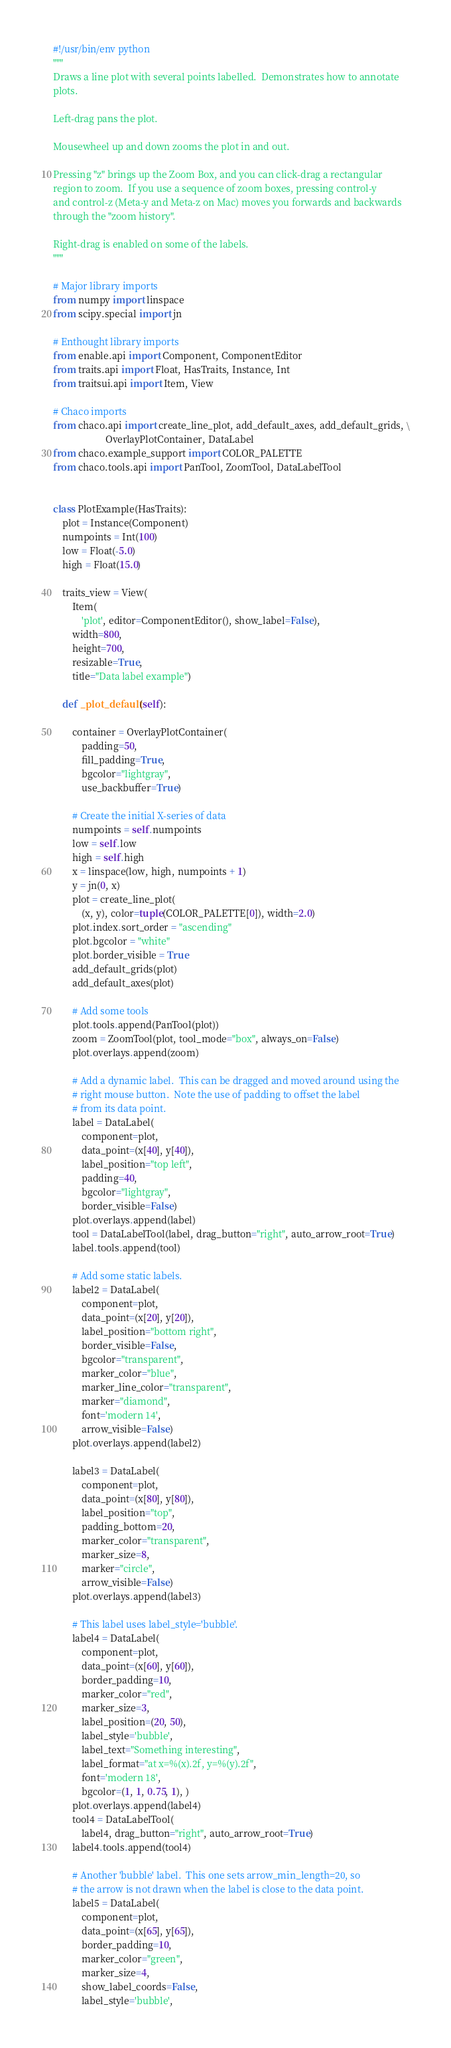<code> <loc_0><loc_0><loc_500><loc_500><_Python_>#!/usr/bin/env python
"""
Draws a line plot with several points labelled.  Demonstrates how to annotate
plots.

Left-drag pans the plot.

Mousewheel up and down zooms the plot in and out.

Pressing "z" brings up the Zoom Box, and you can click-drag a rectangular
region to zoom.  If you use a sequence of zoom boxes, pressing control-y
and control-z (Meta-y and Meta-z on Mac) moves you forwards and backwards
through the "zoom history".

Right-drag is enabled on some of the labels.
"""

# Major library imports
from numpy import linspace
from scipy.special import jn

# Enthought library imports
from enable.api import Component, ComponentEditor
from traits.api import Float, HasTraits, Instance, Int
from traitsui.api import Item, View

# Chaco imports
from chaco.api import create_line_plot, add_default_axes, add_default_grids, \
                      OverlayPlotContainer, DataLabel
from chaco.example_support import COLOR_PALETTE
from chaco.tools.api import PanTool, ZoomTool, DataLabelTool


class PlotExample(HasTraits):
    plot = Instance(Component)
    numpoints = Int(100)
    low = Float(-5.0)
    high = Float(15.0)

    traits_view = View(
        Item(
            'plot', editor=ComponentEditor(), show_label=False),
        width=800,
        height=700,
        resizable=True,
        title="Data label example")

    def _plot_default(self):

        container = OverlayPlotContainer(
            padding=50,
            fill_padding=True,
            bgcolor="lightgray",
            use_backbuffer=True)

        # Create the initial X-series of data
        numpoints = self.numpoints
        low = self.low
        high = self.high
        x = linspace(low, high, numpoints + 1)
        y = jn(0, x)
        plot = create_line_plot(
            (x, y), color=tuple(COLOR_PALETTE[0]), width=2.0)
        plot.index.sort_order = "ascending"
        plot.bgcolor = "white"
        plot.border_visible = True
        add_default_grids(plot)
        add_default_axes(plot)

        # Add some tools
        plot.tools.append(PanTool(plot))
        zoom = ZoomTool(plot, tool_mode="box", always_on=False)
        plot.overlays.append(zoom)

        # Add a dynamic label.  This can be dragged and moved around using the
        # right mouse button.  Note the use of padding to offset the label
        # from its data point.
        label = DataLabel(
            component=plot,
            data_point=(x[40], y[40]),
            label_position="top left",
            padding=40,
            bgcolor="lightgray",
            border_visible=False)
        plot.overlays.append(label)
        tool = DataLabelTool(label, drag_button="right", auto_arrow_root=True)
        label.tools.append(tool)

        # Add some static labels.
        label2 = DataLabel(
            component=plot,
            data_point=(x[20], y[20]),
            label_position="bottom right",
            border_visible=False,
            bgcolor="transparent",
            marker_color="blue",
            marker_line_color="transparent",
            marker="diamond",
            font='modern 14',
            arrow_visible=False)
        plot.overlays.append(label2)

        label3 = DataLabel(
            component=plot,
            data_point=(x[80], y[80]),
            label_position="top",
            padding_bottom=20,
            marker_color="transparent",
            marker_size=8,
            marker="circle",
            arrow_visible=False)
        plot.overlays.append(label3)

        # This label uses label_style='bubble'.
        label4 = DataLabel(
            component=plot,
            data_point=(x[60], y[60]),
            border_padding=10,
            marker_color="red",
            marker_size=3,
            label_position=(20, 50),
            label_style='bubble',
            label_text="Something interesting",
            label_format="at x=%(x).2f, y=%(y).2f",
            font='modern 18',
            bgcolor=(1, 1, 0.75, 1), )
        plot.overlays.append(label4)
        tool4 = DataLabelTool(
            label4, drag_button="right", auto_arrow_root=True)
        label4.tools.append(tool4)

        # Another 'bubble' label.  This one sets arrow_min_length=20, so
        # the arrow is not drawn when the label is close to the data point.
        label5 = DataLabel(
            component=plot,
            data_point=(x[65], y[65]),
            border_padding=10,
            marker_color="green",
            marker_size=4,
            show_label_coords=False,
            label_style='bubble',</code> 